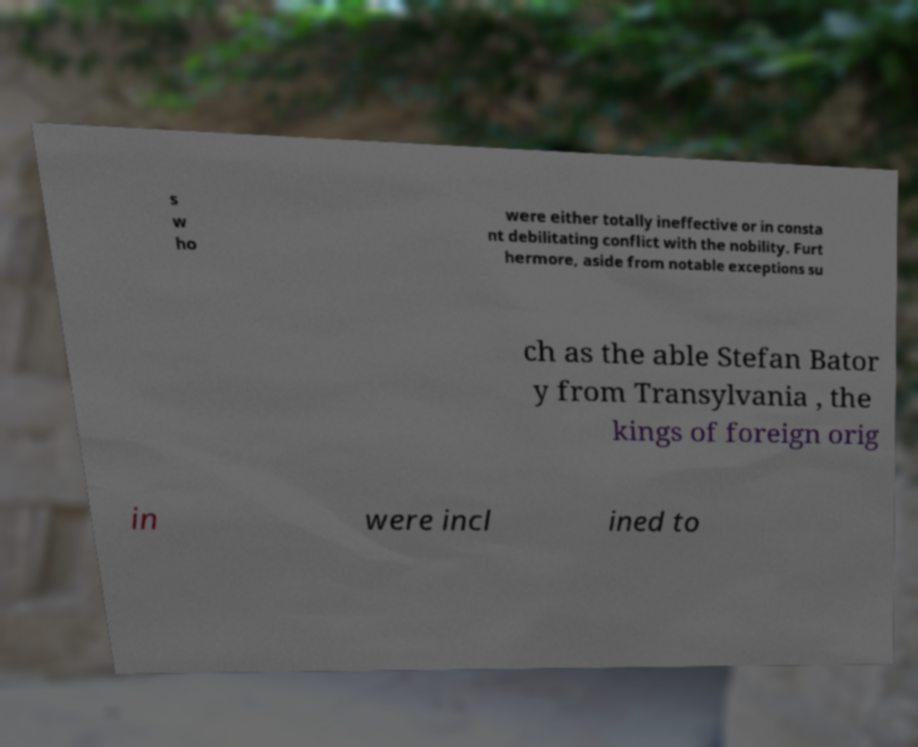There's text embedded in this image that I need extracted. Can you transcribe it verbatim? s w ho were either totally ineffective or in consta nt debilitating conflict with the nobility. Furt hermore, aside from notable exceptions su ch as the able Stefan Bator y from Transylvania , the kings of foreign orig in were incl ined to 